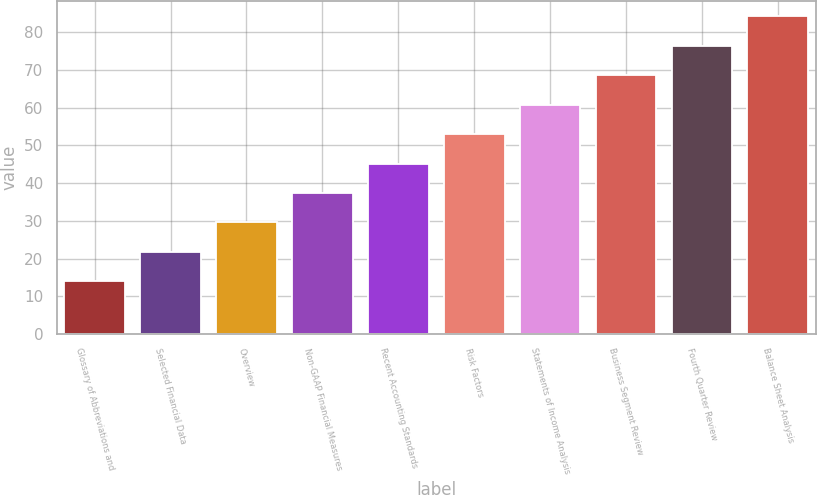Convert chart to OTSL. <chart><loc_0><loc_0><loc_500><loc_500><bar_chart><fcel>Glossary of Abbreviations and<fcel>Selected Financial Data<fcel>Overview<fcel>Non-GAAP Financial Measures<fcel>Recent Accounting Standards<fcel>Risk Factors<fcel>Statements of Income Analysis<fcel>Business Segment Review<fcel>Fourth Quarter Review<fcel>Balance Sheet Analysis<nl><fcel>14<fcel>21.8<fcel>29.6<fcel>37.4<fcel>45.2<fcel>53<fcel>60.8<fcel>68.6<fcel>76.4<fcel>84.2<nl></chart> 